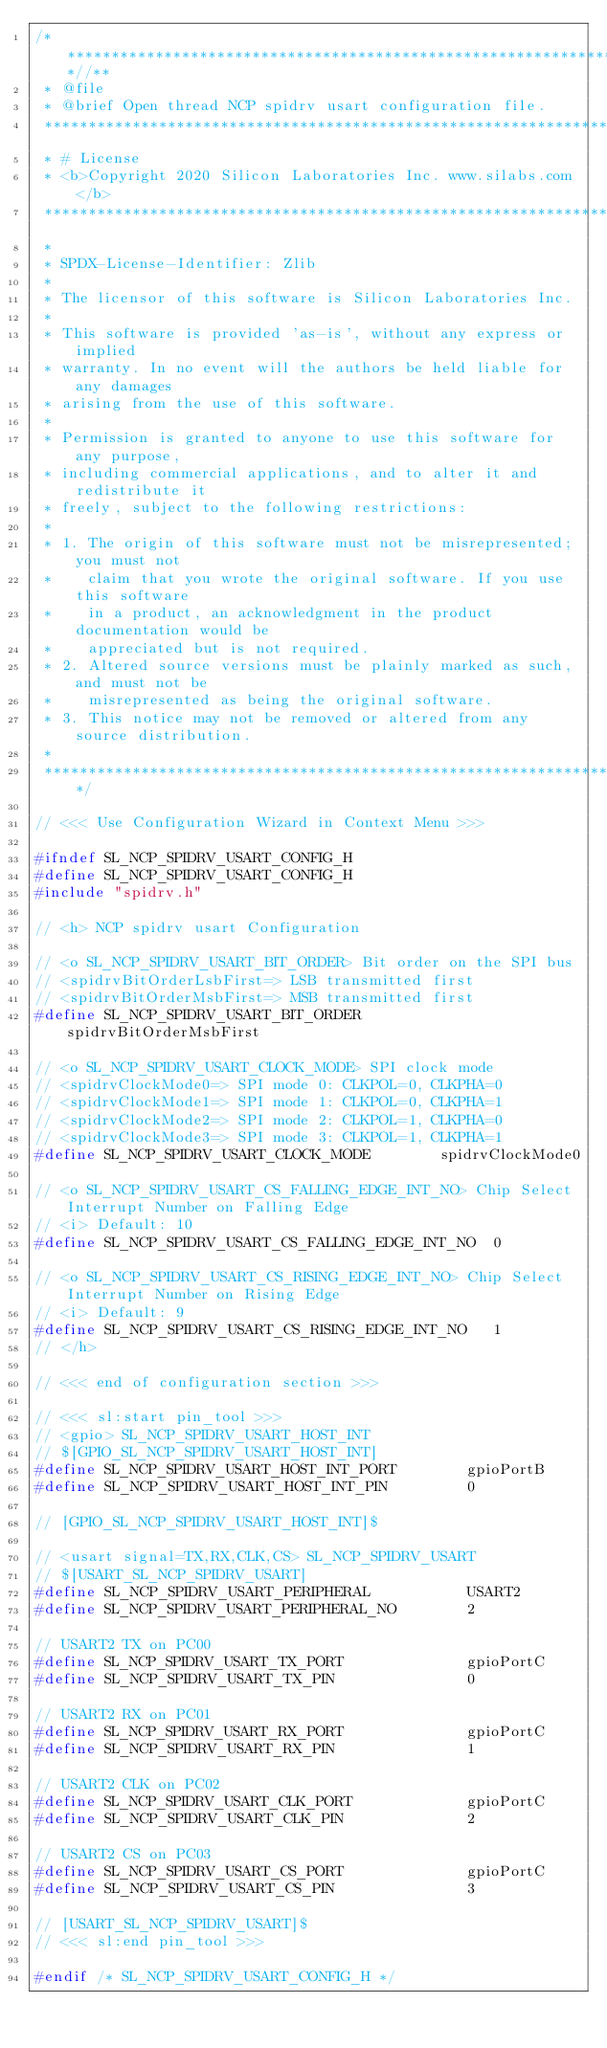Convert code to text. <code><loc_0><loc_0><loc_500><loc_500><_C_>/***************************************************************************//**
 * @file
 * @brief Open thread NCP spidrv usart configuration file.
 *******************************************************************************
 * # License
 * <b>Copyright 2020 Silicon Laboratories Inc. www.silabs.com</b>
 *******************************************************************************
 *
 * SPDX-License-Identifier: Zlib
 *
 * The licensor of this software is Silicon Laboratories Inc.
 *
 * This software is provided 'as-is', without any express or implied
 * warranty. In no event will the authors be held liable for any damages
 * arising from the use of this software.
 *
 * Permission is granted to anyone to use this software for any purpose,
 * including commercial applications, and to alter it and redistribute it
 * freely, subject to the following restrictions:
 *
 * 1. The origin of this software must not be misrepresented; you must not
 *    claim that you wrote the original software. If you use this software
 *    in a product, an acknowledgment in the product documentation would be
 *    appreciated but is not required.
 * 2. Altered source versions must be plainly marked as such, and must not be
 *    misrepresented as being the original software.
 * 3. This notice may not be removed or altered from any source distribution.
 *
 ******************************************************************************/

// <<< Use Configuration Wizard in Context Menu >>>

#ifndef SL_NCP_SPIDRV_USART_CONFIG_H
#define SL_NCP_SPIDRV_USART_CONFIG_H
#include "spidrv.h"

// <h> NCP spidrv usart Configuration

// <o SL_NCP_SPIDRV_USART_BIT_ORDER> Bit order on the SPI bus
// <spidrvBitOrderLsbFirst=> LSB transmitted first
// <spidrvBitOrderMsbFirst=> MSB transmitted first
#define SL_NCP_SPIDRV_USART_BIT_ORDER         spidrvBitOrderMsbFirst

// <o SL_NCP_SPIDRV_USART_CLOCK_MODE> SPI clock mode
// <spidrvClockMode0=> SPI mode 0: CLKPOL=0, CLKPHA=0
// <spidrvClockMode1=> SPI mode 1: CLKPOL=0, CLKPHA=1
// <spidrvClockMode2=> SPI mode 2: CLKPOL=1, CLKPHA=0
// <spidrvClockMode3=> SPI mode 3: CLKPOL=1, CLKPHA=1
#define SL_NCP_SPIDRV_USART_CLOCK_MODE        spidrvClockMode0

// <o SL_NCP_SPIDRV_USART_CS_FALLING_EDGE_INT_NO> Chip Select Interrupt Number on Falling Edge
// <i> Default: 10
#define SL_NCP_SPIDRV_USART_CS_FALLING_EDGE_INT_NO  0

// <o SL_NCP_SPIDRV_USART_CS_RISING_EDGE_INT_NO> Chip Select Interrupt Number on Rising Edge
// <i> Default: 9
#define SL_NCP_SPIDRV_USART_CS_RISING_EDGE_INT_NO   1
// </h>

// <<< end of configuration section >>>

// <<< sl:start pin_tool >>>
// <gpio> SL_NCP_SPIDRV_USART_HOST_INT
// $[GPIO_SL_NCP_SPIDRV_USART_HOST_INT]
#define SL_NCP_SPIDRV_USART_HOST_INT_PORT        gpioPortB
#define SL_NCP_SPIDRV_USART_HOST_INT_PIN         0

// [GPIO_SL_NCP_SPIDRV_USART_HOST_INT]$

// <usart signal=TX,RX,CLK,CS> SL_NCP_SPIDRV_USART
// $[USART_SL_NCP_SPIDRV_USART]
#define SL_NCP_SPIDRV_USART_PERIPHERAL           USART2
#define SL_NCP_SPIDRV_USART_PERIPHERAL_NO        2

// USART2 TX on PC00
#define SL_NCP_SPIDRV_USART_TX_PORT              gpioPortC
#define SL_NCP_SPIDRV_USART_TX_PIN               0

// USART2 RX on PC01
#define SL_NCP_SPIDRV_USART_RX_PORT              gpioPortC
#define SL_NCP_SPIDRV_USART_RX_PIN               1

// USART2 CLK on PC02
#define SL_NCP_SPIDRV_USART_CLK_PORT             gpioPortC
#define SL_NCP_SPIDRV_USART_CLK_PIN              2

// USART2 CS on PC03
#define SL_NCP_SPIDRV_USART_CS_PORT              gpioPortC
#define SL_NCP_SPIDRV_USART_CS_PIN               3

// [USART_SL_NCP_SPIDRV_USART]$
// <<< sl:end pin_tool >>>

#endif /* SL_NCP_SPIDRV_USART_CONFIG_H */
</code> 